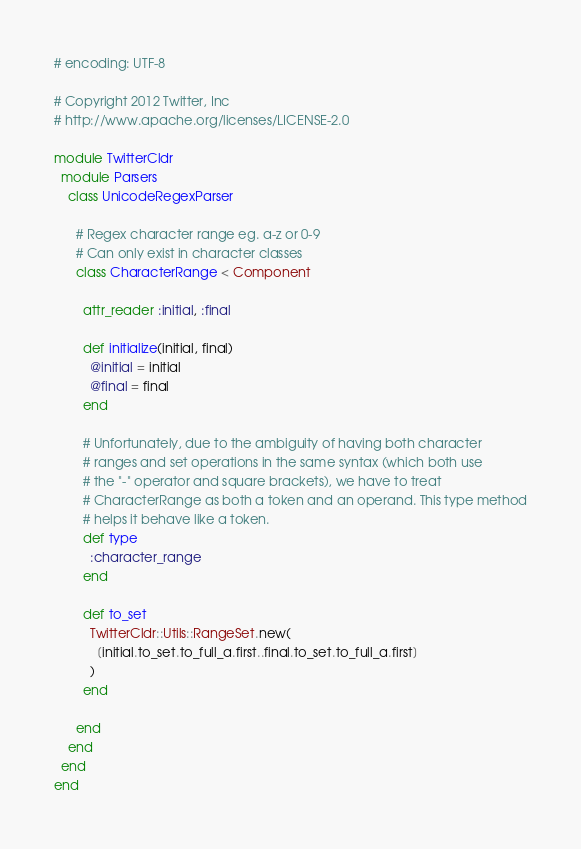<code> <loc_0><loc_0><loc_500><loc_500><_Ruby_># encoding: UTF-8

# Copyright 2012 Twitter, Inc
# http://www.apache.org/licenses/LICENSE-2.0

module TwitterCldr
  module Parsers
    class UnicodeRegexParser

      # Regex character range eg. a-z or 0-9
      # Can only exist in character classes
      class CharacterRange < Component

        attr_reader :initial, :final

        def initialize(initial, final)
          @initial = initial
          @final = final
        end

        # Unfortunately, due to the ambiguity of having both character
        # ranges and set operations in the same syntax (which both use
        # the "-" operator and square brackets), we have to treat
        # CharacterRange as both a token and an operand. This type method
        # helps it behave like a token.
        def type
          :character_range
        end

        def to_set
          TwitterCldr::Utils::RangeSet.new(
            [initial.to_set.to_full_a.first..final.to_set.to_full_a.first]
          )
        end

      end
    end
  end
end
</code> 